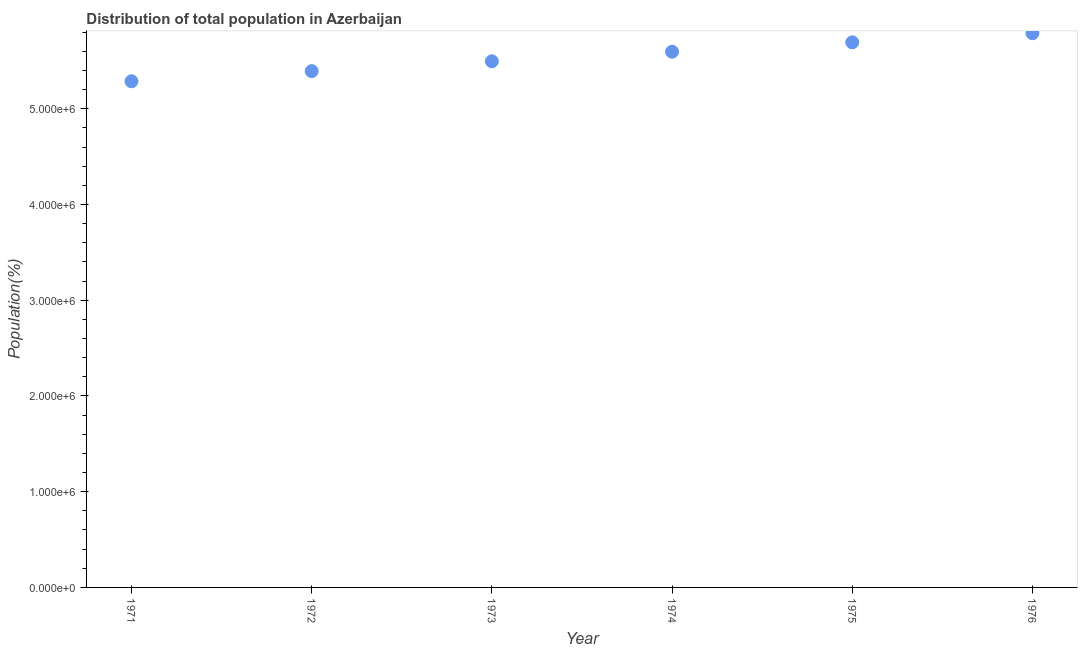What is the population in 1976?
Offer a very short reply. 5.79e+06. Across all years, what is the maximum population?
Ensure brevity in your answer.  5.79e+06. Across all years, what is the minimum population?
Your response must be concise. 5.29e+06. In which year was the population maximum?
Your answer should be very brief. 1976. What is the sum of the population?
Make the answer very short. 3.33e+07. What is the difference between the population in 1971 and 1975?
Keep it short and to the point. -4.07e+05. What is the average population per year?
Keep it short and to the point. 5.54e+06. What is the median population?
Keep it short and to the point. 5.55e+06. In how many years, is the population greater than 4400000 %?
Provide a short and direct response. 6. Do a majority of the years between 1971 and 1976 (inclusive) have population greater than 4000000 %?
Ensure brevity in your answer.  Yes. What is the ratio of the population in 1974 to that in 1975?
Give a very brief answer. 0.98. Is the population in 1971 less than that in 1976?
Your answer should be compact. Yes. Is the difference between the population in 1971 and 1973 greater than the difference between any two years?
Your answer should be very brief. No. What is the difference between the highest and the second highest population?
Give a very brief answer. 9.53e+04. What is the difference between the highest and the lowest population?
Offer a terse response. 5.02e+05. In how many years, is the population greater than the average population taken over all years?
Give a very brief answer. 3. Does the graph contain grids?
Provide a short and direct response. No. What is the title of the graph?
Keep it short and to the point. Distribution of total population in Azerbaijan . What is the label or title of the X-axis?
Offer a terse response. Year. What is the label or title of the Y-axis?
Your answer should be compact. Population(%). What is the Population(%) in 1971?
Provide a short and direct response. 5.29e+06. What is the Population(%) in 1972?
Your answer should be compact. 5.39e+06. What is the Population(%) in 1973?
Your response must be concise. 5.50e+06. What is the Population(%) in 1974?
Give a very brief answer. 5.60e+06. What is the Population(%) in 1975?
Your answer should be very brief. 5.69e+06. What is the Population(%) in 1976?
Give a very brief answer. 5.79e+06. What is the difference between the Population(%) in 1971 and 1972?
Make the answer very short. -1.06e+05. What is the difference between the Population(%) in 1971 and 1973?
Give a very brief answer. -2.09e+05. What is the difference between the Population(%) in 1971 and 1974?
Keep it short and to the point. -3.09e+05. What is the difference between the Population(%) in 1971 and 1975?
Your answer should be compact. -4.07e+05. What is the difference between the Population(%) in 1971 and 1976?
Provide a succinct answer. -5.02e+05. What is the difference between the Population(%) in 1972 and 1973?
Give a very brief answer. -1.03e+05. What is the difference between the Population(%) in 1972 and 1974?
Offer a very short reply. -2.03e+05. What is the difference between the Population(%) in 1972 and 1975?
Ensure brevity in your answer.  -3.01e+05. What is the difference between the Population(%) in 1972 and 1976?
Offer a terse response. -3.96e+05. What is the difference between the Population(%) in 1973 and 1974?
Provide a succinct answer. -1.00e+05. What is the difference between the Population(%) in 1973 and 1975?
Your answer should be very brief. -1.98e+05. What is the difference between the Population(%) in 1973 and 1976?
Provide a short and direct response. -2.93e+05. What is the difference between the Population(%) in 1974 and 1975?
Provide a short and direct response. -9.76e+04. What is the difference between the Population(%) in 1974 and 1976?
Offer a very short reply. -1.93e+05. What is the difference between the Population(%) in 1975 and 1976?
Your answer should be compact. -9.53e+04. What is the ratio of the Population(%) in 1971 to that in 1974?
Give a very brief answer. 0.94. What is the ratio of the Population(%) in 1971 to that in 1975?
Your response must be concise. 0.93. What is the ratio of the Population(%) in 1972 to that in 1975?
Keep it short and to the point. 0.95. What is the ratio of the Population(%) in 1972 to that in 1976?
Offer a very short reply. 0.93. What is the ratio of the Population(%) in 1973 to that in 1974?
Provide a short and direct response. 0.98. What is the ratio of the Population(%) in 1973 to that in 1975?
Your response must be concise. 0.96. What is the ratio of the Population(%) in 1973 to that in 1976?
Ensure brevity in your answer.  0.95. What is the ratio of the Population(%) in 1974 to that in 1975?
Keep it short and to the point. 0.98. What is the ratio of the Population(%) in 1974 to that in 1976?
Give a very brief answer. 0.97. What is the ratio of the Population(%) in 1975 to that in 1976?
Make the answer very short. 0.98. 